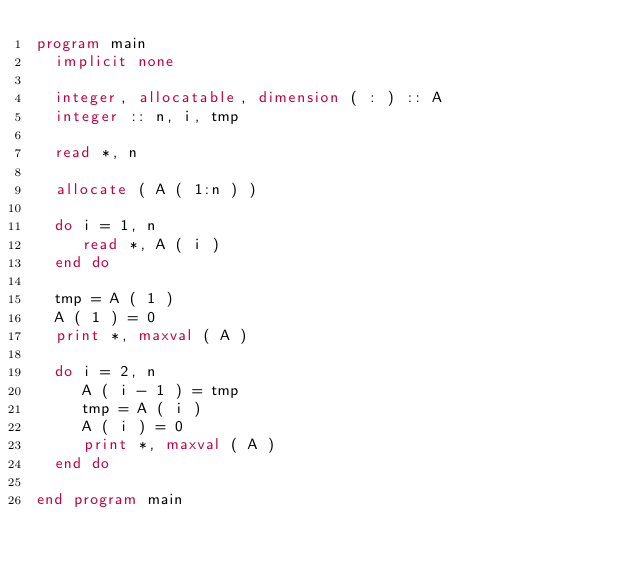<code> <loc_0><loc_0><loc_500><loc_500><_FORTRAN_>program main
  implicit none

  integer, allocatable, dimension ( : ) :: A
  integer :: n, i, tmp

  read *, n

  allocate ( A ( 1:n ) )
  
  do i = 1, n
     read *, A ( i )
  end do
  
  tmp = A ( 1 )
  A ( 1 ) = 0
  print *, maxval ( A )
  
  do i = 2, n
     A ( i - 1 ) = tmp
     tmp = A ( i )
     A ( i ) = 0
     print *, maxval ( A )
  end do

end program main
</code> 